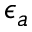<formula> <loc_0><loc_0><loc_500><loc_500>\epsilon _ { a }</formula> 